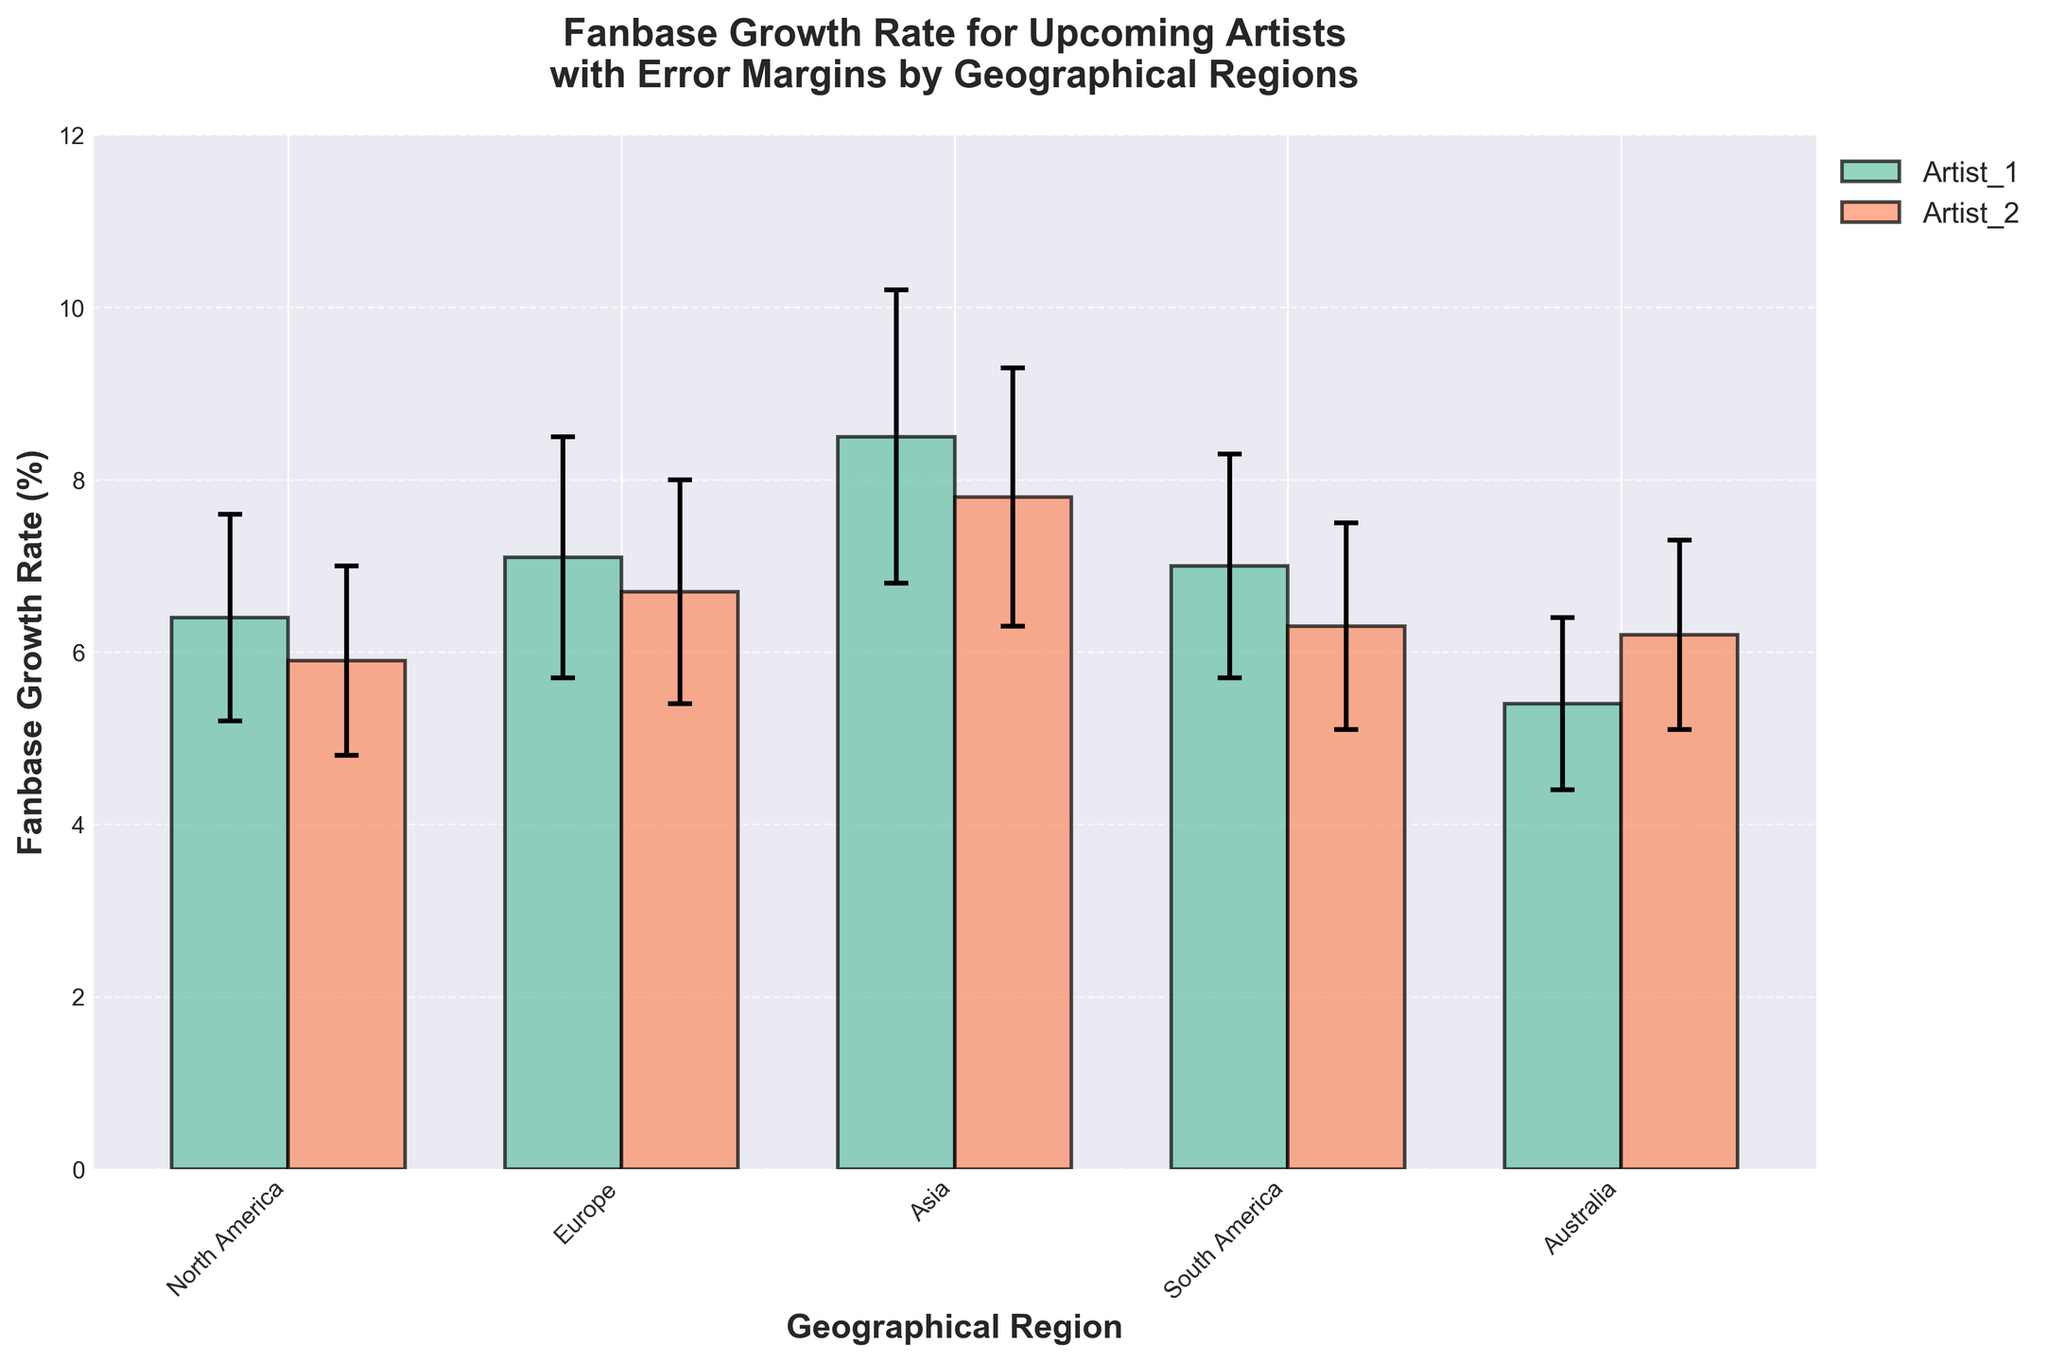What is the title of the figure? The title usually appears at the top of the figure and summarizes the main topic.
Answer: Fanbase Growth Rate for Upcoming Artists with Error Margins by Geographical Regions Which region has the highest fanbase growth rate? To find this, look at the bar heights to compare the growth rates for each region. The tallest bar represents the highest growth rate.
Answer: Asia What is the fanbase growth rate and error margin for Dua Lipa in Europe? Locate the bar for Dua Lipa in Europe, then read the value of the bar height (fanbase growth rate) and the error margin represented by vertical error bars.
Answer: 7.1%, 1.4% What is the difference in fanbase growth rate between Billie Eilish and Lil Nas X in North America? Identify the growth rates for both artists in North America, then subtract Lil Nas X's growth rate from Billie Eilish's growth rate.
Answer: 0.5% Which artist has the largest error margin in Asia? Compare the error margins for BTS and BLACKPINK in Asia by looking at the length of their error bars.
Answer: BTS How does the fanbase growth rate of South America compare to Australia for the first listed artist in each region? Identify the growth rates for Anitta in South America and Tones and I in Australia, then compare these values.
Answer: South America (7.0%) is higher than Australia (5.4%) In which regions do any artists have a fanbase growth rate above 7%? Check each region's growth rates, considering any bar that exceeds a height of 7%.
Answer: Europe, Asia, South America What is the average fanbase growth rate for artists in Australia? Find the fanbase growth rates for both artists in Australia, sum these values and divide by the number of artists (2).
Answer: (5.4 + 6.2) / 2 = 5.8% Which artist in Europe has a higher fanbase growth rate? Compare the heights of the bars for Dua Lipa and Stormzy in Europe and identify the taller one.
Answer: Dua Lipa What is the error margin range for the listed artists in Europe? Identify the length of the shortest and the longest error bars for artists in Europe.
Answer: 1.3% to 1.4% 